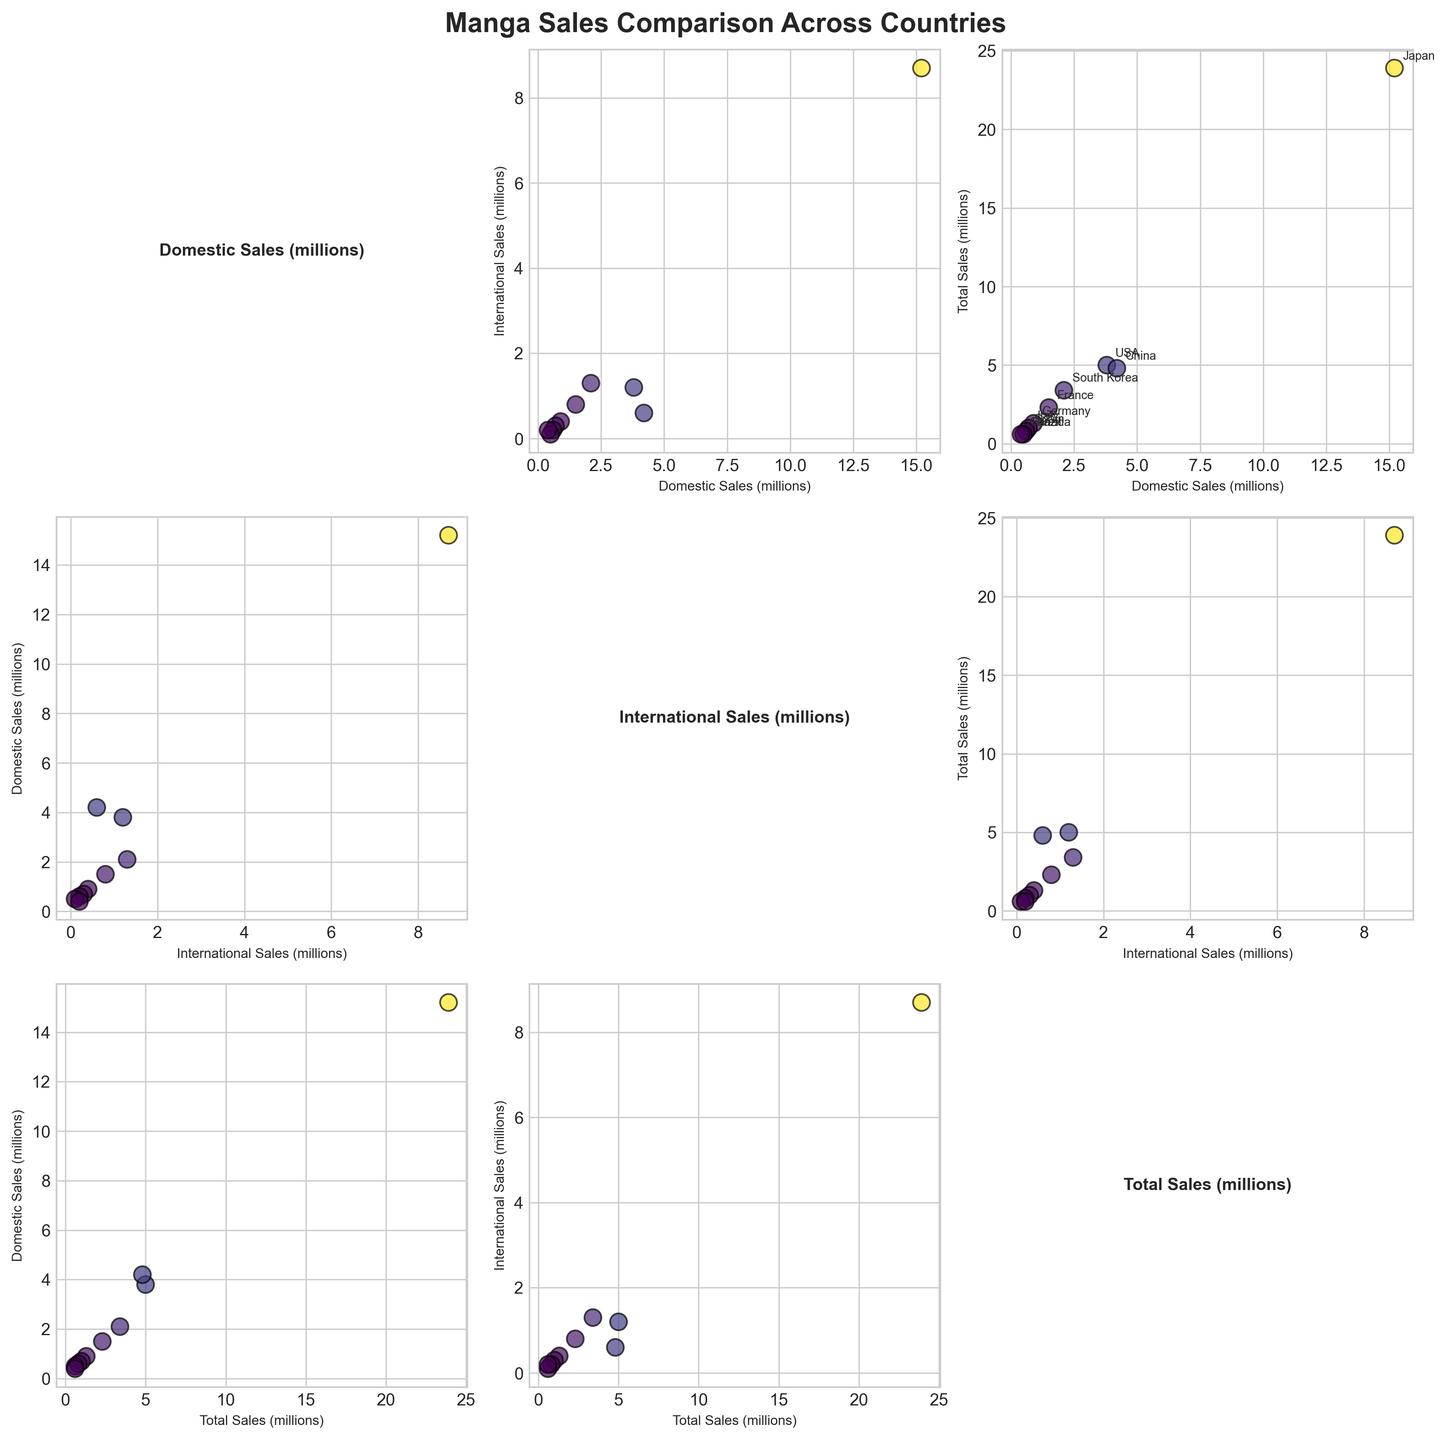What is the title of the scatterplot matrix? The title of a figure is usually found at the top and provides an overall description of the visual representation. Here, it's "Manga Sales Comparison Across Countries."
Answer: Manga Sales Comparison Across Countries Which variable has the highest domestic sales? The scatterplot matrix plots the domestic sales for each country. Japan is the point farthest to the right in the Domestic Sales axis, indicating it has the highest domestic sales.
Answer: Japan Among France and Germany, which country has higher total sales and by how much? First locate France and Germany on the Total Sales (millions) axis. France has a total sales value of 2.3 million, whereas Germany has 1.3 million. The difference is 2.3 - 1.3 = 1 million.
Answer: France by 1 million Is there a country with higher domestic sales but lower international sales compared to China? China has domestic sales of 4.2 million and international sales of 0.6 million. Japan has higher domestic sales (15.2 million) and higher international sales (8.7 million), so look for another candidate. No other country fits these criteria based on the scatter matrix.
Answer: No Which countries have higher total sales than the USA? The USA has total sales of 5.0 million. On the Total Sales (millions) axis, the countries with points higher than 5.0 million are only Japan with 23.9 million.
Answer: Japan How does the relationship between domestic and international sales vary across countries visually? In the scatterplot matrix, look at the scatter subplots comparing Domestic Sales (millions) to International Sales (millions). Japan's point is significantly higher in both, while others show varying levels. It indicates a positive correlation but with different intensities.
Answer: Positively correlated yet varied How many countries have a domestic sales figure under 1 million? Check the scatter subplot with Domestic Sales (millions) and count the points that are below the 1 million mark. Identify countries like Germany, Italy, Spain, Brazil, and Canada falling below this threshold.
Answer: 5 Comparing the Domestic and Total Sales plot, is there an outlier? In the subplot comparing Domestic Sales (millions) with Total Sales (millions), look for points that significantly deviate. Japan stands out significantly higher than the others, making it an outlier.
Answer: Japan Which pairs of variables are annotated with country names? In the scatterplot matrix, annotations are present in some scatter plots. Annotations are added to the subplot comparing 'Domestic Sales (millions)' to 'Total Sales (millions)' as it is marked with country names for those specific points.
Answer: Domestic Sales vs. Total Sales Does any country have the same value for international and domestic sales? Comparing the values in the subplot "Domestic Sales (millions)" vs. "International Sales (millions)", no points fall along the line y=x, indicating equal values.
Answer: No 